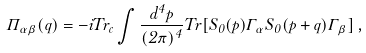Convert formula to latex. <formula><loc_0><loc_0><loc_500><loc_500>\Pi _ { \alpha \beta } ( q ) = - i T r _ { c } \int \frac { d ^ { 4 } p } { ( 2 \pi ) ^ { 4 } } T r [ S _ { 0 } ( p ) \Gamma _ { \alpha } S _ { 0 } ( p + q ) \Gamma _ { \beta } ] \, ,</formula> 